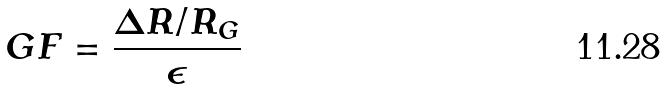Convert formula to latex. <formula><loc_0><loc_0><loc_500><loc_500>G F = \frac { \Delta R / R _ { G } } { \epsilon }</formula> 